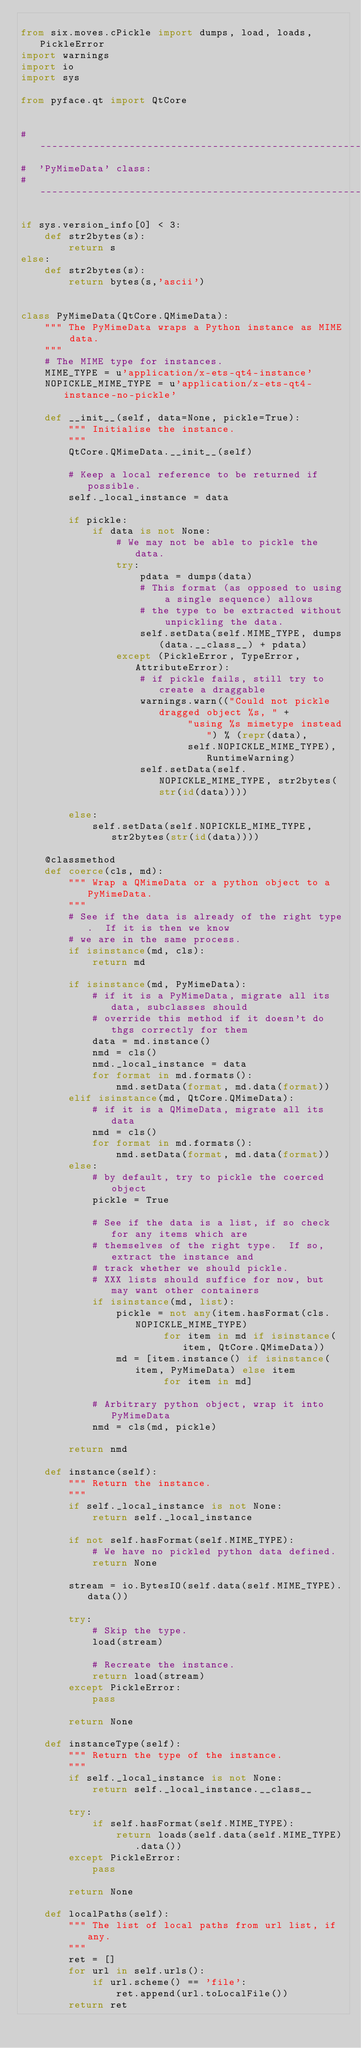Convert code to text. <code><loc_0><loc_0><loc_500><loc_500><_Python_>
from six.moves.cPickle import dumps, load, loads, PickleError
import warnings
import io
import sys

from pyface.qt import QtCore


#-------------------------------------------------------------------------------
#  'PyMimeData' class:
#-------------------------------------------------------------------------------

if sys.version_info[0] < 3:
    def str2bytes(s):
        return s
else:
    def str2bytes(s):
        return bytes(s,'ascii')


class PyMimeData(QtCore.QMimeData):
    """ The PyMimeData wraps a Python instance as MIME data.
    """
    # The MIME type for instances.
    MIME_TYPE = u'application/x-ets-qt4-instance'
    NOPICKLE_MIME_TYPE = u'application/x-ets-qt4-instance-no-pickle'

    def __init__(self, data=None, pickle=True):
        """ Initialise the instance.
        """
        QtCore.QMimeData.__init__(self)

        # Keep a local reference to be returned if possible.
        self._local_instance = data

        if pickle:
            if data is not None:
                # We may not be able to pickle the data.
                try:
                    pdata = dumps(data)
                    # This format (as opposed to using a single sequence) allows
                    # the type to be extracted without unpickling the data.
                    self.setData(self.MIME_TYPE, dumps(data.__class__) + pdata)
                except (PickleError, TypeError, AttributeError):
                    # if pickle fails, still try to create a draggable
                    warnings.warn(("Could not pickle dragged object %s, " +
                            "using %s mimetype instead") % (repr(data),
                            self.NOPICKLE_MIME_TYPE), RuntimeWarning)
                    self.setData(self.NOPICKLE_MIME_TYPE, str2bytes(str(id(data))))

        else:
            self.setData(self.NOPICKLE_MIME_TYPE, str2bytes(str(id(data))))

    @classmethod
    def coerce(cls, md):
        """ Wrap a QMimeData or a python object to a PyMimeData.
        """
        # See if the data is already of the right type.  If it is then we know
        # we are in the same process.
        if isinstance(md, cls):
            return md

        if isinstance(md, PyMimeData):
            # if it is a PyMimeData, migrate all its data, subclasses should
            # override this method if it doesn't do thgs correctly for them
            data = md.instance()
            nmd = cls()
            nmd._local_instance = data
            for format in md.formats():
                nmd.setData(format, md.data(format))
        elif isinstance(md, QtCore.QMimeData):
            # if it is a QMimeData, migrate all its data
            nmd = cls()
            for format in md.formats():
                nmd.setData(format, md.data(format))
        else:
            # by default, try to pickle the coerced object
            pickle = True

            # See if the data is a list, if so check for any items which are
            # themselves of the right type.  If so, extract the instance and
            # track whether we should pickle.
            # XXX lists should suffice for now, but may want other containers
            if isinstance(md, list):
                pickle = not any(item.hasFormat(cls.NOPICKLE_MIME_TYPE)
                        for item in md if isinstance(item, QtCore.QMimeData))
                md = [item.instance() if isinstance(item, PyMimeData) else item
                        for item in md]

            # Arbitrary python object, wrap it into PyMimeData
            nmd = cls(md, pickle)

        return nmd

    def instance(self):
        """ Return the instance.
        """
        if self._local_instance is not None:
            return self._local_instance

        if not self.hasFormat(self.MIME_TYPE):
            # We have no pickled python data defined.
            return None

        stream = io.BytesIO(self.data(self.MIME_TYPE).data())

        try:
            # Skip the type.
            load(stream)

            # Recreate the instance.
            return load(stream)
        except PickleError:
            pass

        return None

    def instanceType(self):
        """ Return the type of the instance.
        """
        if self._local_instance is not None:
            return self._local_instance.__class__

        try:
            if self.hasFormat(self.MIME_TYPE):
                return loads(self.data(self.MIME_TYPE).data())
        except PickleError:
            pass

        return None

    def localPaths(self):
        """ The list of local paths from url list, if any.
        """
        ret = []
        for url in self.urls():
            if url.scheme() == 'file':
                ret.append(url.toLocalFile())
        return ret
</code> 